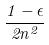<formula> <loc_0><loc_0><loc_500><loc_500>\frac { 1 - \epsilon } { 2 n ^ { 2 } }</formula> 